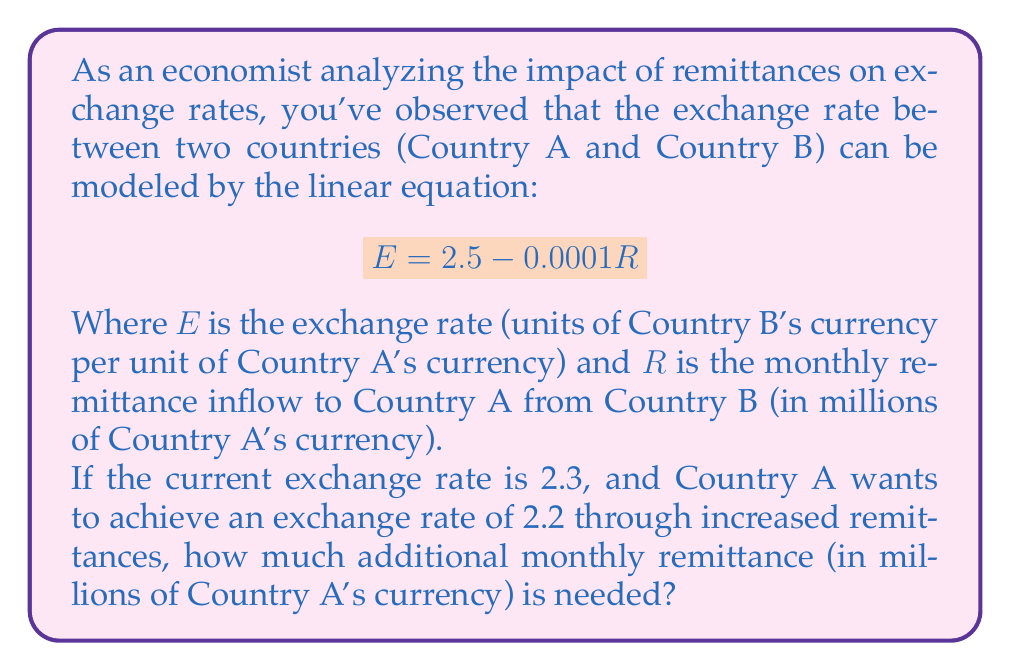Show me your answer to this math problem. To solve this problem, we'll follow these steps:

1) We start with the given equation:
   $$E = 2.5 - 0.0001R$$

2) We know the current exchange rate is 2.3. Let's call the current remittance $R_1$. We can write:
   $$2.3 = 2.5 - 0.0001R_1$$

3) We want to achieve an exchange rate of 2.2. Let's call the new remittance $R_2$. We can write:
   $$2.2 = 2.5 - 0.0001R_2$$

4) To find $R_1$, we solve the equation from step 2:
   $$0.0001R_1 = 2.5 - 2.3 = 0.2$$
   $$R_1 = 2000$$ million

5) To find $R_2$, we solve the equation from step 3:
   $$0.0001R_2 = 2.5 - 2.2 = 0.3$$
   $$R_2 = 3000$$ million

6) The additional remittance needed is the difference between $R_2$ and $R_1$:
   $$R_2 - R_1 = 3000 - 2000 = 1000$$ million

Therefore, an additional 1000 million in monthly remittances is needed to achieve the desired exchange rate.
Answer: An additional 1000 million of Country A's currency in monthly remittances is needed. 